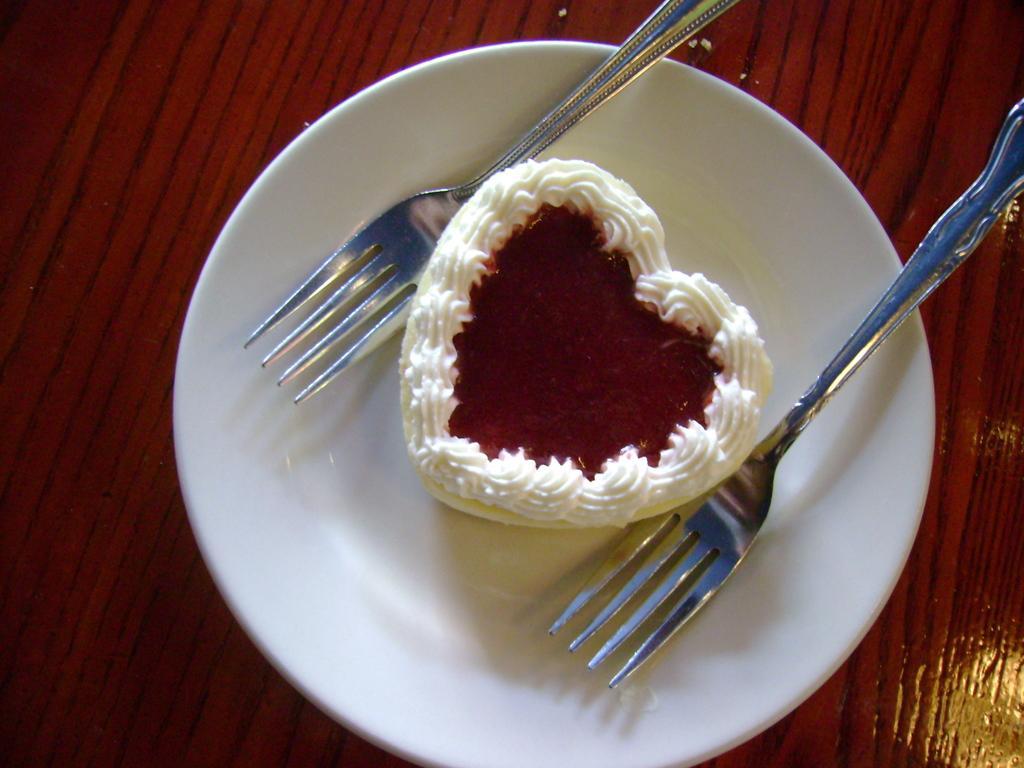In one or two sentences, can you explain what this image depicts? Here we can see a plate, forks, and a cake on a wooden platform. 